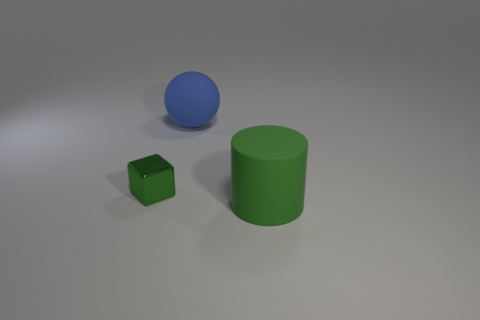Subtract 1 balls. How many balls are left? 0 Subtract all blue cylinders. Subtract all blue balls. How many cylinders are left? 1 Subtract all purple balls. How many yellow blocks are left? 0 Subtract all gray shiny cylinders. Subtract all green cylinders. How many objects are left? 2 Add 1 big blue things. How many big blue things are left? 2 Add 3 big green objects. How many big green objects exist? 4 Add 2 big green things. How many objects exist? 5 Subtract 0 brown balls. How many objects are left? 3 